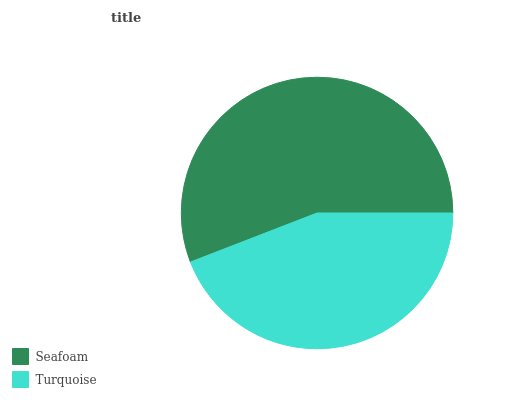Is Turquoise the minimum?
Answer yes or no. Yes. Is Seafoam the maximum?
Answer yes or no. Yes. Is Turquoise the maximum?
Answer yes or no. No. Is Seafoam greater than Turquoise?
Answer yes or no. Yes. Is Turquoise less than Seafoam?
Answer yes or no. Yes. Is Turquoise greater than Seafoam?
Answer yes or no. No. Is Seafoam less than Turquoise?
Answer yes or no. No. Is Seafoam the high median?
Answer yes or no. Yes. Is Turquoise the low median?
Answer yes or no. Yes. Is Turquoise the high median?
Answer yes or no. No. Is Seafoam the low median?
Answer yes or no. No. 